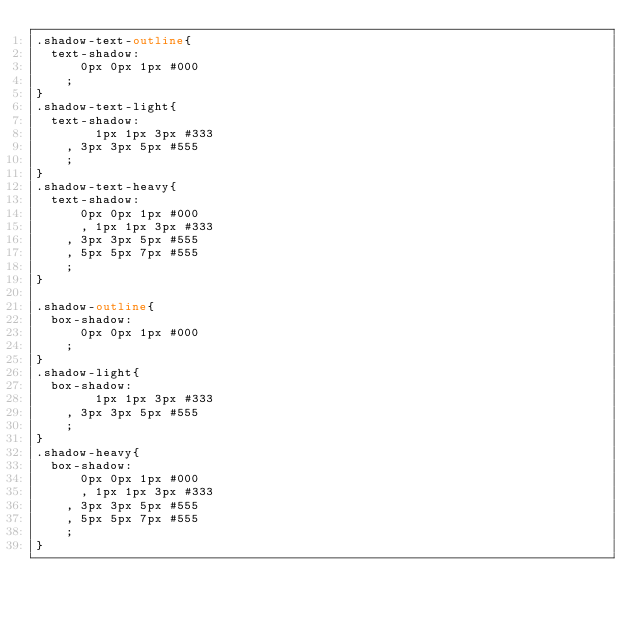Convert code to text. <code><loc_0><loc_0><loc_500><loc_500><_CSS_>.shadow-text-outline{
	text-shadow:
		  0px 0px 1px #000
		;
}
.shadow-text-light{
	text-shadow:
	  	  1px 1px 3px #333
		, 3px 3px 5px #555
		;
}
.shadow-text-heavy{
	text-shadow:
		  0px 0px 1px #000
	  	, 1px 1px 3px #333
		, 3px 3px 5px #555
		, 5px 5px 7px #555
		;
}

.shadow-outline{
	box-shadow:
		  0px 0px 1px #000
		;
}
.shadow-light{
	box-shadow:
	  	  1px 1px 3px #333
		, 3px 3px 5px #555
		;
}
.shadow-heavy{
	box-shadow:
		  0px 0px 1px #000
	  	, 1px 1px 3px #333
		, 3px 3px 5px #555
		, 5px 5px 7px #555
		;
}
</code> 